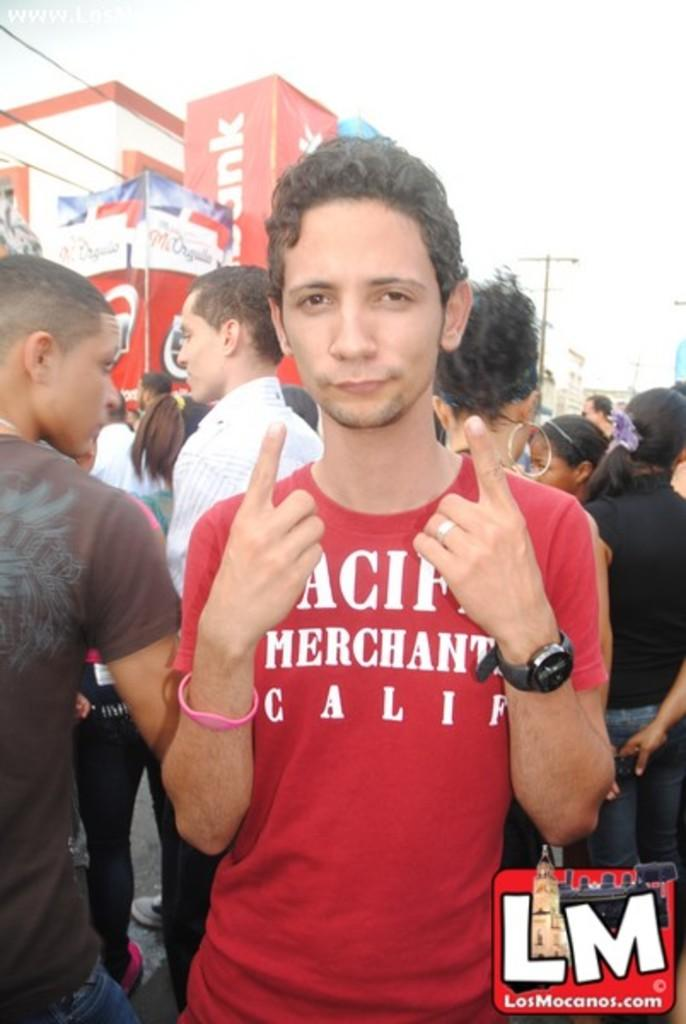What is the person in the image wearing? The person is wearing a red t-shirt. What is the person doing with their fingers? The person is showing their fingers. What can be seen in the background of the image? There are many people standing on the road and a building in the background. What is visible above the building? The sky is visible above the building. How many cows are present in the image? There are no cows present in the image. What type of government is depicted in the image? There is no depiction of a government in the image. 